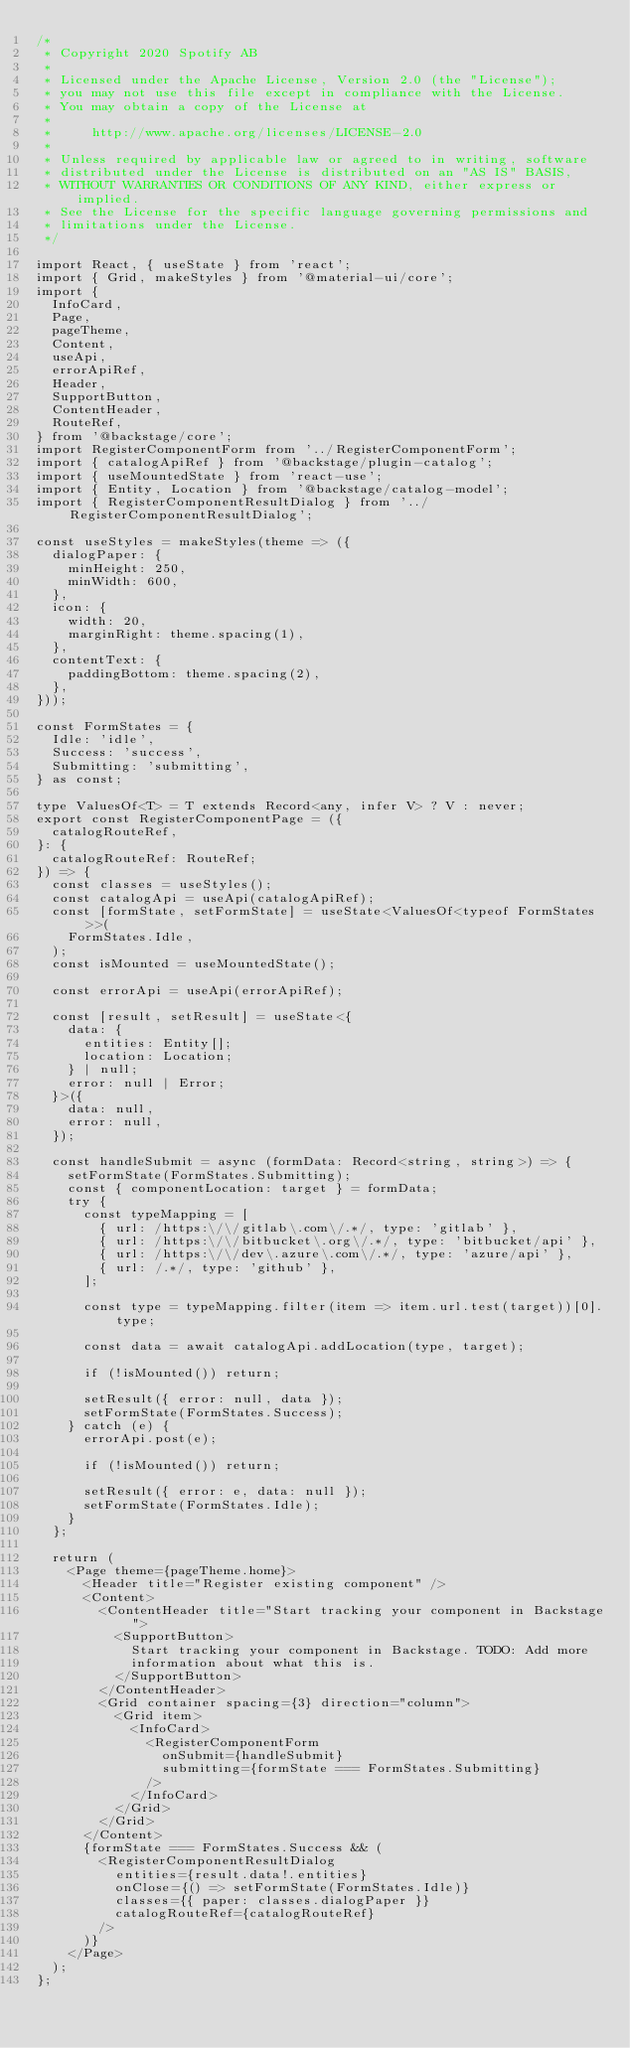Convert code to text. <code><loc_0><loc_0><loc_500><loc_500><_TypeScript_>/*
 * Copyright 2020 Spotify AB
 *
 * Licensed under the Apache License, Version 2.0 (the "License");
 * you may not use this file except in compliance with the License.
 * You may obtain a copy of the License at
 *
 *     http://www.apache.org/licenses/LICENSE-2.0
 *
 * Unless required by applicable law or agreed to in writing, software
 * distributed under the License is distributed on an "AS IS" BASIS,
 * WITHOUT WARRANTIES OR CONDITIONS OF ANY KIND, either express or implied.
 * See the License for the specific language governing permissions and
 * limitations under the License.
 */

import React, { useState } from 'react';
import { Grid, makeStyles } from '@material-ui/core';
import {
  InfoCard,
  Page,
  pageTheme,
  Content,
  useApi,
  errorApiRef,
  Header,
  SupportButton,
  ContentHeader,
  RouteRef,
} from '@backstage/core';
import RegisterComponentForm from '../RegisterComponentForm';
import { catalogApiRef } from '@backstage/plugin-catalog';
import { useMountedState } from 'react-use';
import { Entity, Location } from '@backstage/catalog-model';
import { RegisterComponentResultDialog } from '../RegisterComponentResultDialog';

const useStyles = makeStyles(theme => ({
  dialogPaper: {
    minHeight: 250,
    minWidth: 600,
  },
  icon: {
    width: 20,
    marginRight: theme.spacing(1),
  },
  contentText: {
    paddingBottom: theme.spacing(2),
  },
}));

const FormStates = {
  Idle: 'idle',
  Success: 'success',
  Submitting: 'submitting',
} as const;

type ValuesOf<T> = T extends Record<any, infer V> ? V : never;
export const RegisterComponentPage = ({
  catalogRouteRef,
}: {
  catalogRouteRef: RouteRef;
}) => {
  const classes = useStyles();
  const catalogApi = useApi(catalogApiRef);
  const [formState, setFormState] = useState<ValuesOf<typeof FormStates>>(
    FormStates.Idle,
  );
  const isMounted = useMountedState();

  const errorApi = useApi(errorApiRef);

  const [result, setResult] = useState<{
    data: {
      entities: Entity[];
      location: Location;
    } | null;
    error: null | Error;
  }>({
    data: null,
    error: null,
  });

  const handleSubmit = async (formData: Record<string, string>) => {
    setFormState(FormStates.Submitting);
    const { componentLocation: target } = formData;
    try {
      const typeMapping = [
        { url: /https:\/\/gitlab\.com\/.*/, type: 'gitlab' },
        { url: /https:\/\/bitbucket\.org\/.*/, type: 'bitbucket/api' },
        { url: /https:\/\/dev\.azure\.com\/.*/, type: 'azure/api' },
        { url: /.*/, type: 'github' },
      ];

      const type = typeMapping.filter(item => item.url.test(target))[0].type;

      const data = await catalogApi.addLocation(type, target);

      if (!isMounted()) return;

      setResult({ error: null, data });
      setFormState(FormStates.Success);
    } catch (e) {
      errorApi.post(e);

      if (!isMounted()) return;

      setResult({ error: e, data: null });
      setFormState(FormStates.Idle);
    }
  };

  return (
    <Page theme={pageTheme.home}>
      <Header title="Register existing component" />
      <Content>
        <ContentHeader title="Start tracking your component in Backstage">
          <SupportButton>
            Start tracking your component in Backstage. TODO: Add more
            information about what this is.
          </SupportButton>
        </ContentHeader>
        <Grid container spacing={3} direction="column">
          <Grid item>
            <InfoCard>
              <RegisterComponentForm
                onSubmit={handleSubmit}
                submitting={formState === FormStates.Submitting}
              />
            </InfoCard>
          </Grid>
        </Grid>
      </Content>
      {formState === FormStates.Success && (
        <RegisterComponentResultDialog
          entities={result.data!.entities}
          onClose={() => setFormState(FormStates.Idle)}
          classes={{ paper: classes.dialogPaper }}
          catalogRouteRef={catalogRouteRef}
        />
      )}
    </Page>
  );
};
</code> 